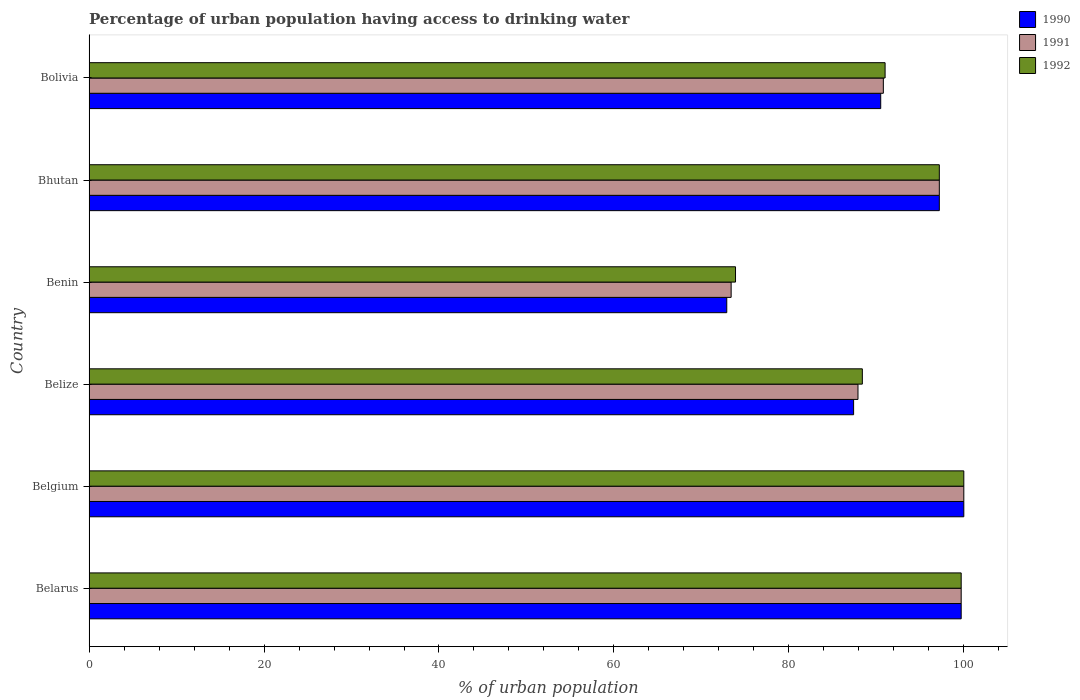Are the number of bars per tick equal to the number of legend labels?
Your response must be concise. Yes. How many bars are there on the 5th tick from the top?
Give a very brief answer. 3. What is the label of the 3rd group of bars from the top?
Keep it short and to the point. Benin. In how many cases, is the number of bars for a given country not equal to the number of legend labels?
Ensure brevity in your answer.  0. Across all countries, what is the maximum percentage of urban population having access to drinking water in 1992?
Provide a short and direct response. 100. Across all countries, what is the minimum percentage of urban population having access to drinking water in 1992?
Keep it short and to the point. 73.9. In which country was the percentage of urban population having access to drinking water in 1992 minimum?
Provide a succinct answer. Benin. What is the total percentage of urban population having access to drinking water in 1992 in the graph?
Your answer should be very brief. 550.2. What is the difference between the percentage of urban population having access to drinking water in 1991 in Belgium and that in Belize?
Your answer should be compact. 12.1. What is the difference between the percentage of urban population having access to drinking water in 1990 in Bolivia and the percentage of urban population having access to drinking water in 1992 in Belize?
Keep it short and to the point. 2.1. What is the average percentage of urban population having access to drinking water in 1991 per country?
Ensure brevity in your answer.  91.5. In how many countries, is the percentage of urban population having access to drinking water in 1990 greater than 92 %?
Give a very brief answer. 3. What is the ratio of the percentage of urban population having access to drinking water in 1990 in Belgium to that in Bolivia?
Your answer should be very brief. 1.1. What is the difference between the highest and the second highest percentage of urban population having access to drinking water in 1992?
Ensure brevity in your answer.  0.3. What is the difference between the highest and the lowest percentage of urban population having access to drinking water in 1992?
Your answer should be compact. 26.1. Is the sum of the percentage of urban population having access to drinking water in 1991 in Belize and Bolivia greater than the maximum percentage of urban population having access to drinking water in 1990 across all countries?
Offer a terse response. Yes. What does the 1st bar from the bottom in Bhutan represents?
Ensure brevity in your answer.  1990. How many bars are there?
Give a very brief answer. 18. What is the difference between two consecutive major ticks on the X-axis?
Provide a succinct answer. 20. Does the graph contain any zero values?
Your response must be concise. No. Does the graph contain grids?
Make the answer very short. No. Where does the legend appear in the graph?
Your response must be concise. Top right. How are the legend labels stacked?
Keep it short and to the point. Vertical. What is the title of the graph?
Give a very brief answer. Percentage of urban population having access to drinking water. What is the label or title of the X-axis?
Provide a short and direct response. % of urban population. What is the label or title of the Y-axis?
Your answer should be compact. Country. What is the % of urban population of 1990 in Belarus?
Your answer should be very brief. 99.7. What is the % of urban population in 1991 in Belarus?
Provide a short and direct response. 99.7. What is the % of urban population of 1992 in Belarus?
Make the answer very short. 99.7. What is the % of urban population of 1990 in Belize?
Your response must be concise. 87.4. What is the % of urban population in 1991 in Belize?
Offer a terse response. 87.9. What is the % of urban population of 1992 in Belize?
Give a very brief answer. 88.4. What is the % of urban population in 1990 in Benin?
Give a very brief answer. 72.9. What is the % of urban population in 1991 in Benin?
Your answer should be compact. 73.4. What is the % of urban population in 1992 in Benin?
Give a very brief answer. 73.9. What is the % of urban population of 1990 in Bhutan?
Ensure brevity in your answer.  97.2. What is the % of urban population of 1991 in Bhutan?
Your response must be concise. 97.2. What is the % of urban population of 1992 in Bhutan?
Your answer should be very brief. 97.2. What is the % of urban population of 1990 in Bolivia?
Provide a short and direct response. 90.5. What is the % of urban population in 1991 in Bolivia?
Make the answer very short. 90.8. What is the % of urban population in 1992 in Bolivia?
Offer a terse response. 91. Across all countries, what is the maximum % of urban population of 1990?
Make the answer very short. 100. Across all countries, what is the minimum % of urban population of 1990?
Offer a very short reply. 72.9. Across all countries, what is the minimum % of urban population in 1991?
Provide a short and direct response. 73.4. Across all countries, what is the minimum % of urban population of 1992?
Give a very brief answer. 73.9. What is the total % of urban population of 1990 in the graph?
Make the answer very short. 547.7. What is the total % of urban population in 1991 in the graph?
Ensure brevity in your answer.  549. What is the total % of urban population in 1992 in the graph?
Provide a short and direct response. 550.2. What is the difference between the % of urban population of 1992 in Belarus and that in Belgium?
Keep it short and to the point. -0.3. What is the difference between the % of urban population in 1991 in Belarus and that in Belize?
Provide a succinct answer. 11.8. What is the difference between the % of urban population in 1990 in Belarus and that in Benin?
Your answer should be very brief. 26.8. What is the difference between the % of urban population of 1991 in Belarus and that in Benin?
Make the answer very short. 26.3. What is the difference between the % of urban population of 1992 in Belarus and that in Benin?
Provide a succinct answer. 25.8. What is the difference between the % of urban population of 1991 in Belarus and that in Bhutan?
Offer a very short reply. 2.5. What is the difference between the % of urban population of 1990 in Belarus and that in Bolivia?
Give a very brief answer. 9.2. What is the difference between the % of urban population of 1992 in Belarus and that in Bolivia?
Offer a very short reply. 8.7. What is the difference between the % of urban population of 1992 in Belgium and that in Belize?
Provide a short and direct response. 11.6. What is the difference between the % of urban population in 1990 in Belgium and that in Benin?
Keep it short and to the point. 27.1. What is the difference between the % of urban population of 1991 in Belgium and that in Benin?
Provide a succinct answer. 26.6. What is the difference between the % of urban population in 1992 in Belgium and that in Benin?
Ensure brevity in your answer.  26.1. What is the difference between the % of urban population of 1990 in Belgium and that in Bhutan?
Provide a succinct answer. 2.8. What is the difference between the % of urban population of 1991 in Belgium and that in Bhutan?
Your answer should be compact. 2.8. What is the difference between the % of urban population of 1992 in Belgium and that in Bhutan?
Give a very brief answer. 2.8. What is the difference between the % of urban population in 1992 in Belgium and that in Bolivia?
Give a very brief answer. 9. What is the difference between the % of urban population in 1990 in Belize and that in Benin?
Offer a terse response. 14.5. What is the difference between the % of urban population in 1991 in Belize and that in Benin?
Make the answer very short. 14.5. What is the difference between the % of urban population of 1990 in Belize and that in Bhutan?
Your answer should be very brief. -9.8. What is the difference between the % of urban population of 1991 in Belize and that in Bhutan?
Make the answer very short. -9.3. What is the difference between the % of urban population of 1990 in Benin and that in Bhutan?
Ensure brevity in your answer.  -24.3. What is the difference between the % of urban population in 1991 in Benin and that in Bhutan?
Keep it short and to the point. -23.8. What is the difference between the % of urban population in 1992 in Benin and that in Bhutan?
Offer a very short reply. -23.3. What is the difference between the % of urban population in 1990 in Benin and that in Bolivia?
Keep it short and to the point. -17.6. What is the difference between the % of urban population of 1991 in Benin and that in Bolivia?
Your response must be concise. -17.4. What is the difference between the % of urban population of 1992 in Benin and that in Bolivia?
Make the answer very short. -17.1. What is the difference between the % of urban population in 1990 in Bhutan and that in Bolivia?
Offer a terse response. 6.7. What is the difference between the % of urban population in 1991 in Bhutan and that in Bolivia?
Provide a succinct answer. 6.4. What is the difference between the % of urban population in 1990 in Belarus and the % of urban population in 1991 in Belgium?
Keep it short and to the point. -0.3. What is the difference between the % of urban population in 1990 in Belarus and the % of urban population in 1992 in Belgium?
Your answer should be compact. -0.3. What is the difference between the % of urban population in 1991 in Belarus and the % of urban population in 1992 in Belgium?
Ensure brevity in your answer.  -0.3. What is the difference between the % of urban population in 1990 in Belarus and the % of urban population in 1992 in Belize?
Provide a short and direct response. 11.3. What is the difference between the % of urban population in 1991 in Belarus and the % of urban population in 1992 in Belize?
Offer a very short reply. 11.3. What is the difference between the % of urban population of 1990 in Belarus and the % of urban population of 1991 in Benin?
Offer a terse response. 26.3. What is the difference between the % of urban population of 1990 in Belarus and the % of urban population of 1992 in Benin?
Your answer should be very brief. 25.8. What is the difference between the % of urban population in 1991 in Belarus and the % of urban population in 1992 in Benin?
Give a very brief answer. 25.8. What is the difference between the % of urban population in 1991 in Belarus and the % of urban population in 1992 in Bhutan?
Keep it short and to the point. 2.5. What is the difference between the % of urban population in 1990 in Belgium and the % of urban population in 1991 in Belize?
Provide a short and direct response. 12.1. What is the difference between the % of urban population of 1990 in Belgium and the % of urban population of 1991 in Benin?
Provide a succinct answer. 26.6. What is the difference between the % of urban population of 1990 in Belgium and the % of urban population of 1992 in Benin?
Offer a very short reply. 26.1. What is the difference between the % of urban population in 1991 in Belgium and the % of urban population in 1992 in Benin?
Offer a very short reply. 26.1. What is the difference between the % of urban population of 1991 in Belgium and the % of urban population of 1992 in Bhutan?
Provide a succinct answer. 2.8. What is the difference between the % of urban population in 1990 in Belgium and the % of urban population in 1991 in Bolivia?
Offer a terse response. 9.2. What is the difference between the % of urban population of 1991 in Belgium and the % of urban population of 1992 in Bolivia?
Keep it short and to the point. 9. What is the difference between the % of urban population of 1990 in Belize and the % of urban population of 1991 in Bolivia?
Your response must be concise. -3.4. What is the difference between the % of urban population in 1990 in Benin and the % of urban population in 1991 in Bhutan?
Provide a succinct answer. -24.3. What is the difference between the % of urban population in 1990 in Benin and the % of urban population in 1992 in Bhutan?
Your answer should be compact. -24.3. What is the difference between the % of urban population of 1991 in Benin and the % of urban population of 1992 in Bhutan?
Keep it short and to the point. -23.8. What is the difference between the % of urban population of 1990 in Benin and the % of urban population of 1991 in Bolivia?
Your answer should be compact. -17.9. What is the difference between the % of urban population in 1990 in Benin and the % of urban population in 1992 in Bolivia?
Your answer should be compact. -18.1. What is the difference between the % of urban population in 1991 in Benin and the % of urban population in 1992 in Bolivia?
Make the answer very short. -17.6. What is the difference between the % of urban population in 1990 in Bhutan and the % of urban population in 1991 in Bolivia?
Provide a succinct answer. 6.4. What is the difference between the % of urban population of 1990 in Bhutan and the % of urban population of 1992 in Bolivia?
Offer a terse response. 6.2. What is the difference between the % of urban population of 1991 in Bhutan and the % of urban population of 1992 in Bolivia?
Ensure brevity in your answer.  6.2. What is the average % of urban population of 1990 per country?
Give a very brief answer. 91.28. What is the average % of urban population in 1991 per country?
Give a very brief answer. 91.5. What is the average % of urban population in 1992 per country?
Provide a succinct answer. 91.7. What is the difference between the % of urban population of 1990 and % of urban population of 1991 in Belize?
Your response must be concise. -0.5. What is the difference between the % of urban population in 1991 and % of urban population in 1992 in Belize?
Make the answer very short. -0.5. What is the difference between the % of urban population in 1990 and % of urban population in 1991 in Benin?
Give a very brief answer. -0.5. What is the difference between the % of urban population in 1990 and % of urban population in 1992 in Benin?
Offer a very short reply. -1. What is the difference between the % of urban population in 1990 and % of urban population in 1991 in Bhutan?
Ensure brevity in your answer.  0. What is the difference between the % of urban population of 1990 and % of urban population of 1992 in Bhutan?
Offer a terse response. 0. What is the difference between the % of urban population of 1990 and % of urban population of 1991 in Bolivia?
Give a very brief answer. -0.3. What is the difference between the % of urban population of 1990 and % of urban population of 1992 in Bolivia?
Your response must be concise. -0.5. What is the ratio of the % of urban population of 1992 in Belarus to that in Belgium?
Provide a succinct answer. 1. What is the ratio of the % of urban population in 1990 in Belarus to that in Belize?
Give a very brief answer. 1.14. What is the ratio of the % of urban population of 1991 in Belarus to that in Belize?
Ensure brevity in your answer.  1.13. What is the ratio of the % of urban population of 1992 in Belarus to that in Belize?
Offer a very short reply. 1.13. What is the ratio of the % of urban population of 1990 in Belarus to that in Benin?
Provide a short and direct response. 1.37. What is the ratio of the % of urban population of 1991 in Belarus to that in Benin?
Offer a very short reply. 1.36. What is the ratio of the % of urban population in 1992 in Belarus to that in Benin?
Your answer should be compact. 1.35. What is the ratio of the % of urban population in 1990 in Belarus to that in Bhutan?
Offer a terse response. 1.03. What is the ratio of the % of urban population of 1991 in Belarus to that in Bhutan?
Give a very brief answer. 1.03. What is the ratio of the % of urban population in 1992 in Belarus to that in Bhutan?
Give a very brief answer. 1.03. What is the ratio of the % of urban population in 1990 in Belarus to that in Bolivia?
Ensure brevity in your answer.  1.1. What is the ratio of the % of urban population of 1991 in Belarus to that in Bolivia?
Your response must be concise. 1.1. What is the ratio of the % of urban population of 1992 in Belarus to that in Bolivia?
Provide a short and direct response. 1.1. What is the ratio of the % of urban population in 1990 in Belgium to that in Belize?
Give a very brief answer. 1.14. What is the ratio of the % of urban population of 1991 in Belgium to that in Belize?
Offer a terse response. 1.14. What is the ratio of the % of urban population in 1992 in Belgium to that in Belize?
Make the answer very short. 1.13. What is the ratio of the % of urban population of 1990 in Belgium to that in Benin?
Offer a terse response. 1.37. What is the ratio of the % of urban population of 1991 in Belgium to that in Benin?
Your answer should be compact. 1.36. What is the ratio of the % of urban population of 1992 in Belgium to that in Benin?
Provide a succinct answer. 1.35. What is the ratio of the % of urban population of 1990 in Belgium to that in Bhutan?
Give a very brief answer. 1.03. What is the ratio of the % of urban population in 1991 in Belgium to that in Bhutan?
Ensure brevity in your answer.  1.03. What is the ratio of the % of urban population of 1992 in Belgium to that in Bhutan?
Keep it short and to the point. 1.03. What is the ratio of the % of urban population in 1990 in Belgium to that in Bolivia?
Your answer should be compact. 1.1. What is the ratio of the % of urban population in 1991 in Belgium to that in Bolivia?
Give a very brief answer. 1.1. What is the ratio of the % of urban population of 1992 in Belgium to that in Bolivia?
Ensure brevity in your answer.  1.1. What is the ratio of the % of urban population in 1990 in Belize to that in Benin?
Provide a short and direct response. 1.2. What is the ratio of the % of urban population in 1991 in Belize to that in Benin?
Your response must be concise. 1.2. What is the ratio of the % of urban population in 1992 in Belize to that in Benin?
Offer a very short reply. 1.2. What is the ratio of the % of urban population in 1990 in Belize to that in Bhutan?
Provide a succinct answer. 0.9. What is the ratio of the % of urban population in 1991 in Belize to that in Bhutan?
Keep it short and to the point. 0.9. What is the ratio of the % of urban population in 1992 in Belize to that in Bhutan?
Your answer should be very brief. 0.91. What is the ratio of the % of urban population of 1990 in Belize to that in Bolivia?
Your response must be concise. 0.97. What is the ratio of the % of urban population in 1991 in Belize to that in Bolivia?
Keep it short and to the point. 0.97. What is the ratio of the % of urban population of 1992 in Belize to that in Bolivia?
Keep it short and to the point. 0.97. What is the ratio of the % of urban population in 1990 in Benin to that in Bhutan?
Your answer should be very brief. 0.75. What is the ratio of the % of urban population of 1991 in Benin to that in Bhutan?
Your response must be concise. 0.76. What is the ratio of the % of urban population of 1992 in Benin to that in Bhutan?
Give a very brief answer. 0.76. What is the ratio of the % of urban population of 1990 in Benin to that in Bolivia?
Ensure brevity in your answer.  0.81. What is the ratio of the % of urban population in 1991 in Benin to that in Bolivia?
Offer a terse response. 0.81. What is the ratio of the % of urban population in 1992 in Benin to that in Bolivia?
Keep it short and to the point. 0.81. What is the ratio of the % of urban population in 1990 in Bhutan to that in Bolivia?
Offer a very short reply. 1.07. What is the ratio of the % of urban population of 1991 in Bhutan to that in Bolivia?
Keep it short and to the point. 1.07. What is the ratio of the % of urban population of 1992 in Bhutan to that in Bolivia?
Offer a terse response. 1.07. What is the difference between the highest and the second highest % of urban population in 1990?
Offer a terse response. 0.3. What is the difference between the highest and the second highest % of urban population in 1992?
Make the answer very short. 0.3. What is the difference between the highest and the lowest % of urban population in 1990?
Offer a very short reply. 27.1. What is the difference between the highest and the lowest % of urban population of 1991?
Offer a terse response. 26.6. What is the difference between the highest and the lowest % of urban population in 1992?
Provide a short and direct response. 26.1. 